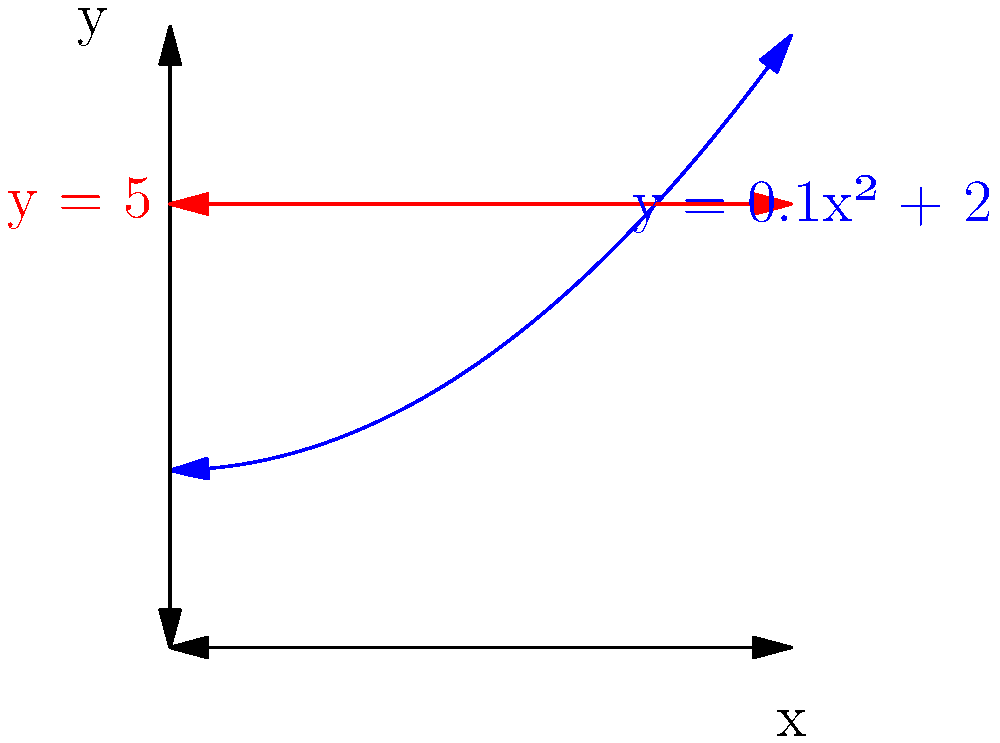A flight path is modeled by the curve $y = 0.1x^2 + 2$, where $x$ and $y$ are measured in hundreds of kilometers. The fuel consumption rate (in liters per hour) is proportional to the square of the aircraft's altitude. If the aircraft maintains a constant horizontal speed of 900 km/h, at what altitude should it fly to minimize fuel consumption for a given distance? To solve this problem, we'll follow these steps:

1) The fuel consumption rate is proportional to $y^2$, so we need to minimize $\int y^2 dx$ over the flight path.

2) We can express this integral in terms of x:
   $$\int (0.1x^2 + 2)^2 dx$$

3) Expanding this:
   $$\int (0.01x^4 + 0.4x^2 + 4) dx$$

4) To minimize this integral, we need to minimize the integrand at each point. This is equivalent to finding the minimum of the function:
   $$f(x) = 0.01x^4 + 0.4x^2 + 4$$

5) The minimum of this function will occur at a constant y-value (a horizontal line on the graph).

6) To find this minimum, we differentiate and set to zero:
   $$f'(x) = 0.04x^3 + 0.8x = 0$$
   $$x(0.04x^2 + 0.8) = 0$$

7) The non-zero solution is when $0.04x^2 + 0.8 = 0$
   $$x^2 = 20$$
   $$x = \sqrt{20} \approx 4.47$$

8) Substituting this back into the original equation:
   $$y = 0.1(4.47)^2 + 2 \approx 4$$

9) Converting to actual altitude: $4 * 100 = 400$ km

Therefore, the aircraft should fly at a constant altitude of approximately 400 km to minimize fuel consumption.
Answer: 400 km 